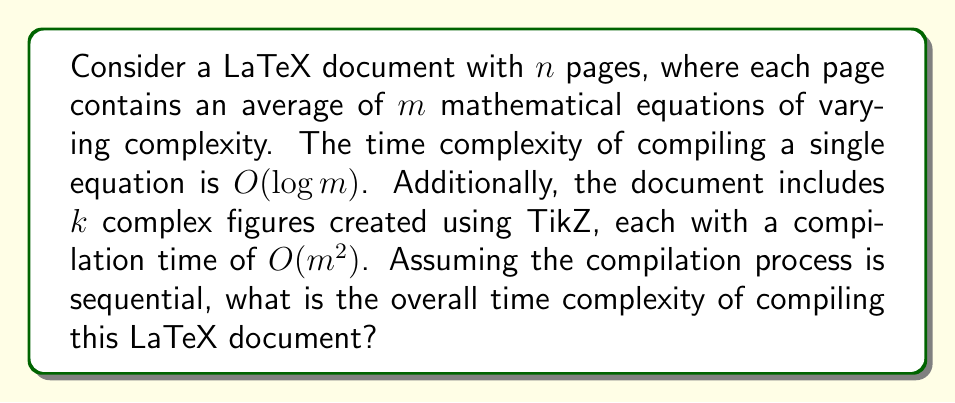Help me with this question. To analyze the time complexity of compiling this LaTeX document, we need to consider the following components:

1. Compilation of text and basic formatting:
   - This typically has a linear time complexity with respect to the number of pages: $O(n)$

2. Compilation of mathematical equations:
   - There are $n$ pages, each with $m$ equations on average
   - Each equation has a compilation time of $O(\log m)$
   - Total time for equations: $O(n \cdot m \cdot \log m)$

3. Compilation of complex TikZ figures:
   - There are $k$ figures, each with a compilation time of $O(m^2)$
   - Total time for figures: $O(k \cdot m^2)$

To determine the overall time complexity, we need to sum these components:

$$T(n,m,k) = O(n) + O(n \cdot m \cdot \log m) + O(k \cdot m^2)$$

Now, we need to identify the dominant term:

- $O(n)$ is generally smaller than $O(n \cdot m \cdot \log m)$ for non-trivial documents
- $O(n \cdot m \cdot \log m)$ and $O(k \cdot m^2)$ need to be compared

The dominant term depends on the relative values of $n$, $m$, and $k$. However, in most practical scenarios, the number of pages $n$ is likely to be larger than the number of complex figures $k$. Therefore, we can generally assume that $O(n \cdot m \cdot \log m)$ is the dominant term.

Thus, the overall time complexity can be expressed as:

$$T(n,m,k) = O(n \cdot m \cdot \log m)$$

This complexity reflects that the compilation time grows with the number of pages, the average number of equations per page, and the logarithm of the equation complexity.
Answer: The overall time complexity of compiling the LaTeX document is $O(n \cdot m \cdot \log m)$, where $n$ is the number of pages and $m$ is the average number of mathematical equations per page. 